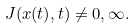<formula> <loc_0><loc_0><loc_500><loc_500>J ( x ( t ) , t ) \neq 0 , \infty .</formula> 